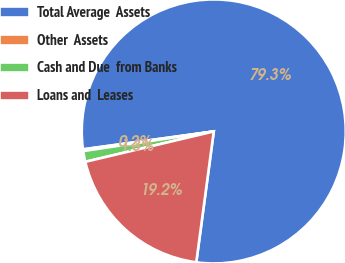Convert chart to OTSL. <chart><loc_0><loc_0><loc_500><loc_500><pie_chart><fcel>Total Average  Assets<fcel>Other  Assets<fcel>Cash and Due  from Banks<fcel>Loans and  Leases<nl><fcel>79.28%<fcel>0.21%<fcel>1.32%<fcel>19.19%<nl></chart> 